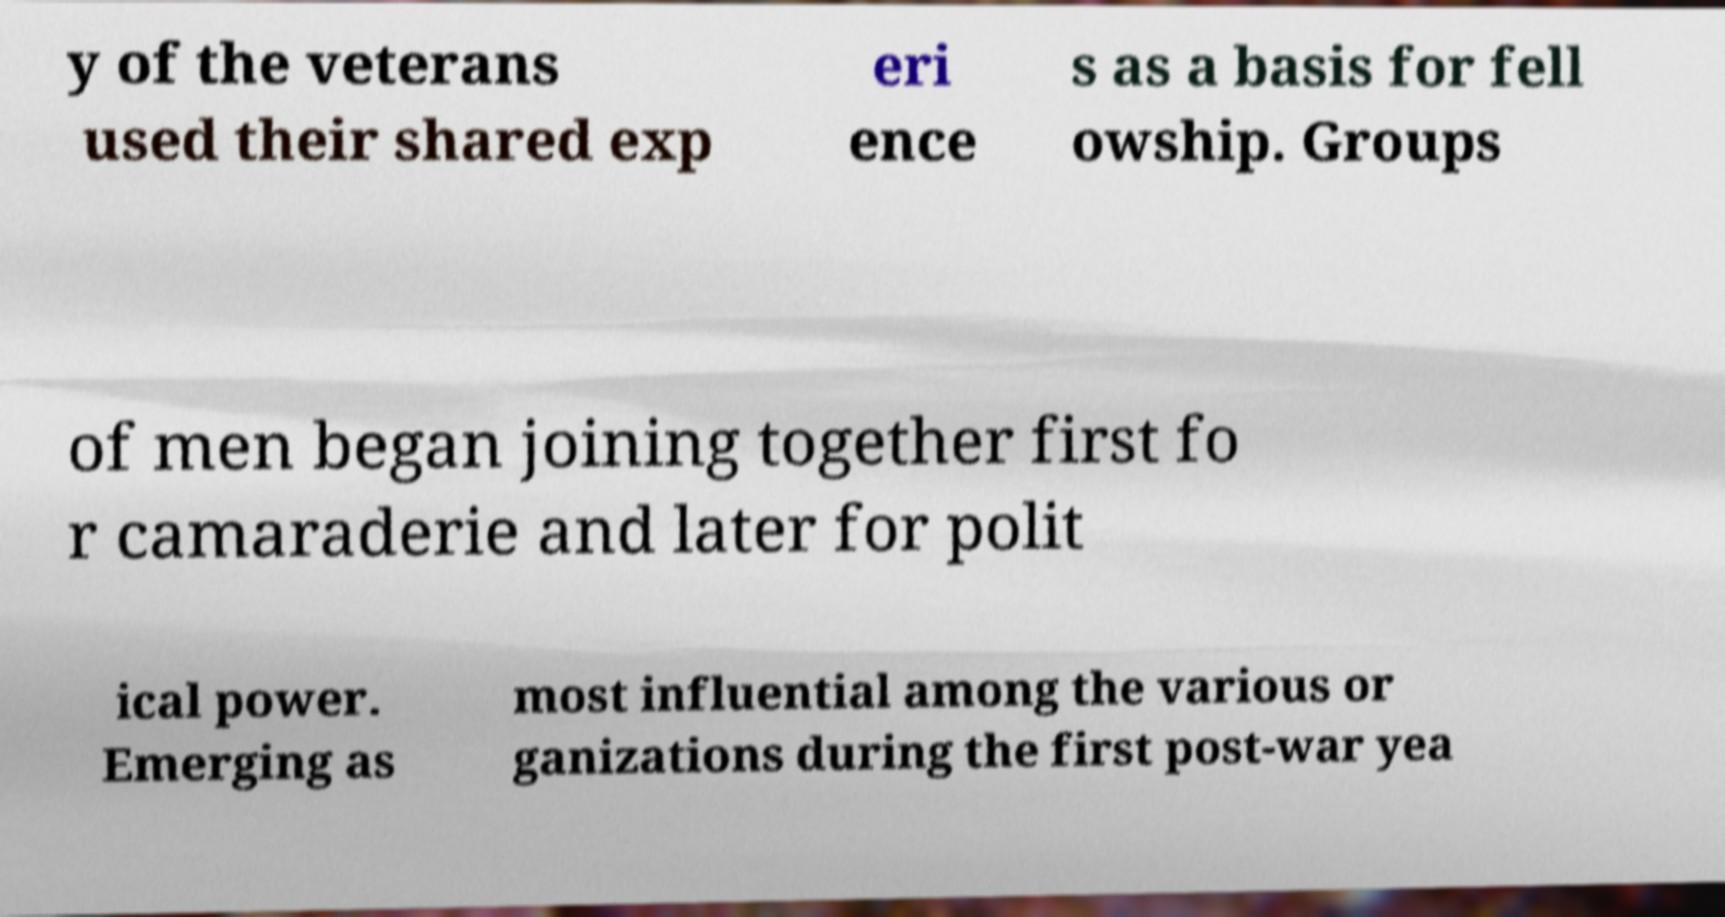Could you extract and type out the text from this image? y of the veterans used their shared exp eri ence s as a basis for fell owship. Groups of men began joining together first fo r camaraderie and later for polit ical power. Emerging as most influential among the various or ganizations during the first post-war yea 